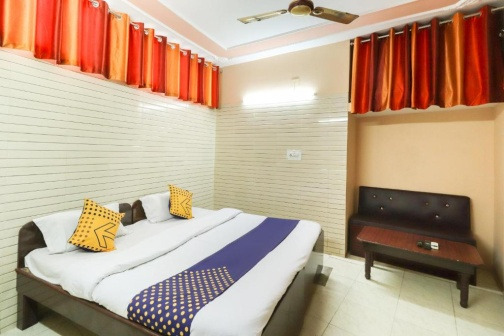How does the design of this room address the need for comfort and functionality? The design of the room effectively marries comfort with functionality through the use of spacious furniture like the large bed and the practical sofa, which both increase the room's utility while ensuring comfort. The inclusion of a ceiling fan addresses the practical need for air circulation, vital for comfort in potentially warm settings. The curtains not only serve a decorative function but also enhance comfort by providing privacy and regulating natural light. 